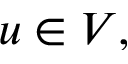Convert formula to latex. <formula><loc_0><loc_0><loc_500><loc_500>u \in V ,</formula> 